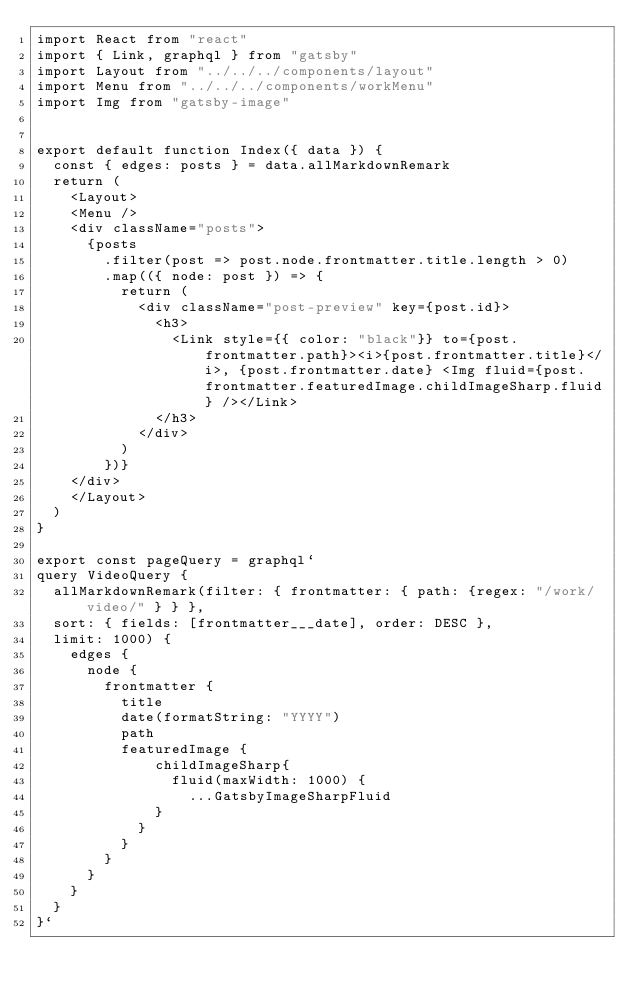<code> <loc_0><loc_0><loc_500><loc_500><_JavaScript_>import React from "react"
import { Link, graphql } from "gatsby"
import Layout from "../../../components/layout"
import Menu from "../../../components/workMenu"
import Img from "gatsby-image"


export default function Index({ data }) {
  const { edges: posts } = data.allMarkdownRemark
  return (
    <Layout>
    <Menu />
    <div className="posts">
      {posts
        .filter(post => post.node.frontmatter.title.length > 0)
        .map(({ node: post }) => {
          return (
            <div className="post-preview" key={post.id}>
              <h3>
                <Link style={{ color: "black"}} to={post.frontmatter.path}><i>{post.frontmatter.title}</i>, {post.frontmatter.date} <Img fluid={post.frontmatter.featuredImage.childImageSharp.fluid} /></Link>
              </h3>
            </div>
          )
        })}
    </div>
    </Layout>
  )
}

export const pageQuery = graphql`
query VideoQuery {
  allMarkdownRemark(filter: { frontmatter: { path: {regex: "/work/video/" } } },
  sort: { fields: [frontmatter___date], order: DESC },
  limit: 1000) {
    edges {
      node {
        frontmatter {
          title
          date(formatString: "YYYY")
          path
          featuredImage {
              childImageSharp{
                fluid(maxWidth: 1000) {
                  ...GatsbyImageSharpFluid
              }
            }
          }
        }
      }
    }
  }
}`
</code> 